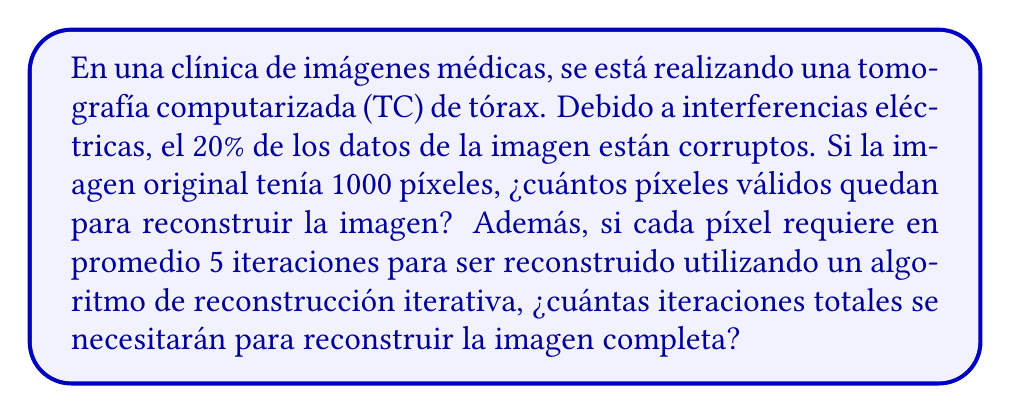Teach me how to tackle this problem. Para resolver este problema, seguiremos estos pasos:

1. Calcular el número de píxeles válidos:
   - La imagen original tiene 1000 píxeles
   - El 20% de los datos están corruptos
   - Por lo tanto, el 80% de los datos son válidos
   - Número de píxeles válidos = $1000 \times 0.80 = 800$ píxeles

2. Calcular el número total de iteraciones:
   - Cada píxel requiere en promedio 5 iteraciones para ser reconstruido
   - Necesitamos reconstruir todos los 1000 píxeles originales
   - Número total de iteraciones = $1000 \times 5 = 5000$ iteraciones

Es importante notar que aunque solo 800 píxeles tienen datos válidos, el algoritmo de reconstrucción iterativa intentará reconstruir la imagen completa de 1000 píxeles utilizando técnicas de interpolación y estimación para los datos faltantes.
Answer: 800 píxeles válidos; 5000 iteraciones totales 